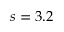<formula> <loc_0><loc_0><loc_500><loc_500>s = 3 . 2</formula> 